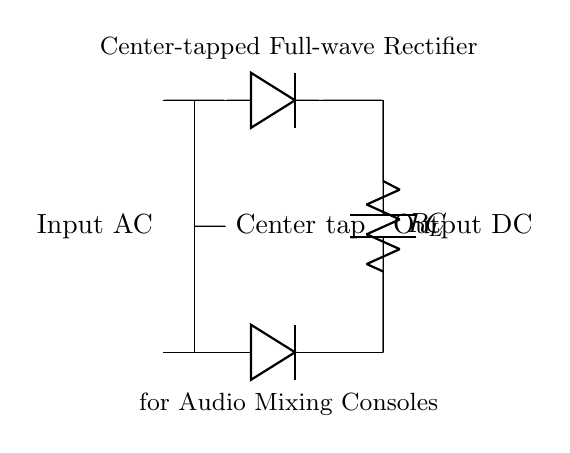What type of rectifier is shown in the diagram? The diagram depicts a full-wave rectifier, which is specifically designed to convert both halves of the AC waveform into DC.
Answer: full-wave rectifier What components are used in this circuit? The circuit includes a transformer, two diodes, a capacitor, and a load resistor. These components work together to convert alternating current to direct current.
Answer: transformer, diodes, capacitor, load resistor What is the purpose of the center tap in this circuit? The center tap serves as a reference point for the AC voltage from the transformer, allowing the two diodes to alternatively conduct and rectify both halves of the AC signal.
Answer: reference point How many diodes are in this rectifier circuit? The circuit contains two diodes, which are essential for the full-wave rectification process to manage both halves of the waveform.
Answer: two What is the function of the capacitor in this rectifier? The capacitor smooths out the fluctuating DC voltage after rectification, providing a more stable output voltage to the load by reducing the ripple.
Answer: smooths voltage What is the expected output waveform type after rectification? The output waveform should be a pulsating DC signal, resembling a continuous line with peaks corresponding to the rectified AC input.
Answer: pulsating DC signal How does this rectifier circuit improve efficiency for audio mixing consoles? This rectifier offers improved efficiency by utilizing both halves of the AC signal, leading to better power usage and less distortion in the audio processing required in mixing consoles.
Answer: improved efficiency 